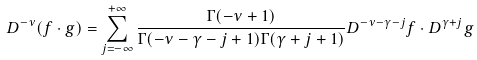<formula> <loc_0><loc_0><loc_500><loc_500>D ^ { - \nu } ( f \cdot g ) = \sum _ { j = - \infty } ^ { + \infty } \frac { \Gamma ( - \nu + 1 ) } { \Gamma ( - \nu - \gamma - j + 1 ) \Gamma ( \gamma + j + 1 ) } D ^ { - \nu - \gamma - j } f \cdot D ^ { \gamma + j } g</formula> 